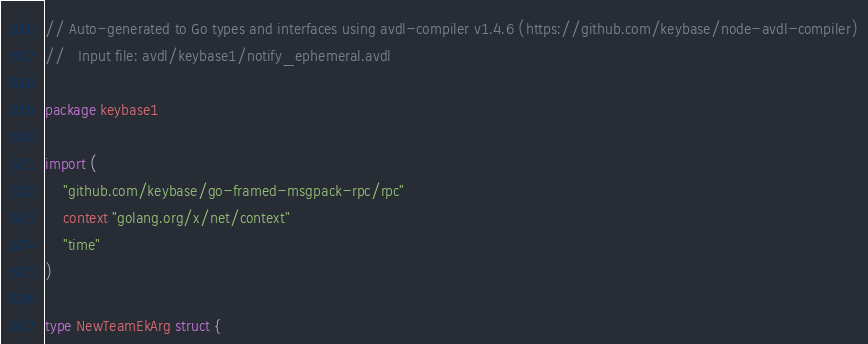<code> <loc_0><loc_0><loc_500><loc_500><_Go_>// Auto-generated to Go types and interfaces using avdl-compiler v1.4.6 (https://github.com/keybase/node-avdl-compiler)
//   Input file: avdl/keybase1/notify_ephemeral.avdl

package keybase1

import (
	"github.com/keybase/go-framed-msgpack-rpc/rpc"
	context "golang.org/x/net/context"
	"time"
)

type NewTeamEkArg struct {</code> 